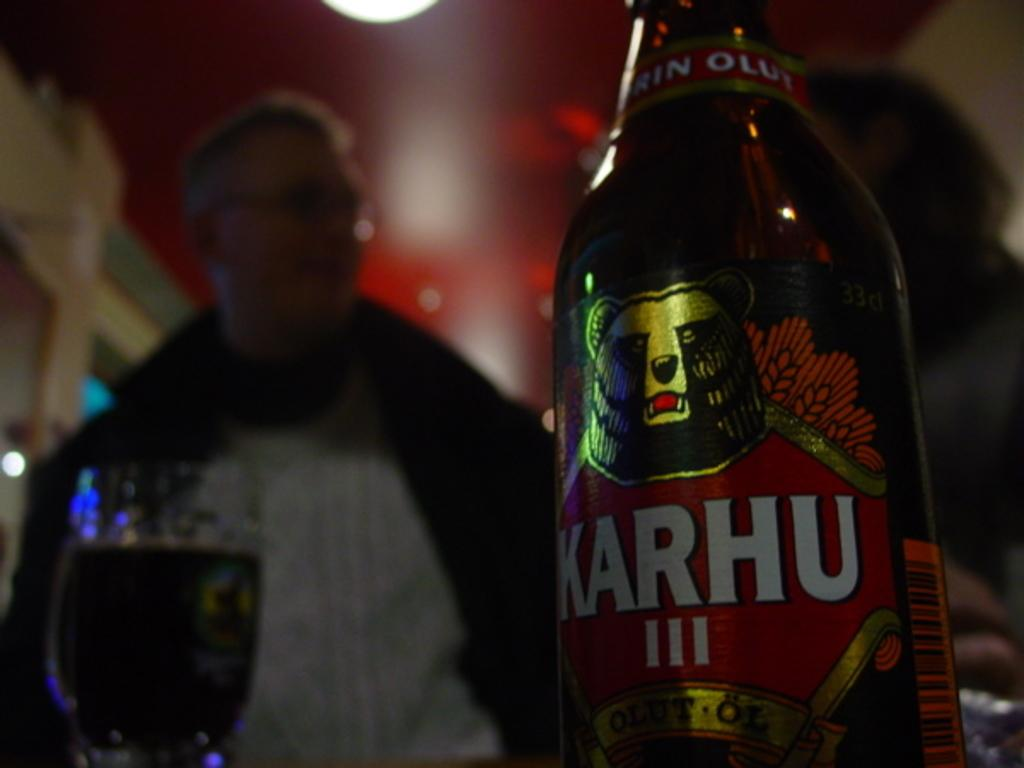<image>
Render a clear and concise summary of the photo. Karhu sits on a table with a glass full and a guy behind it. 